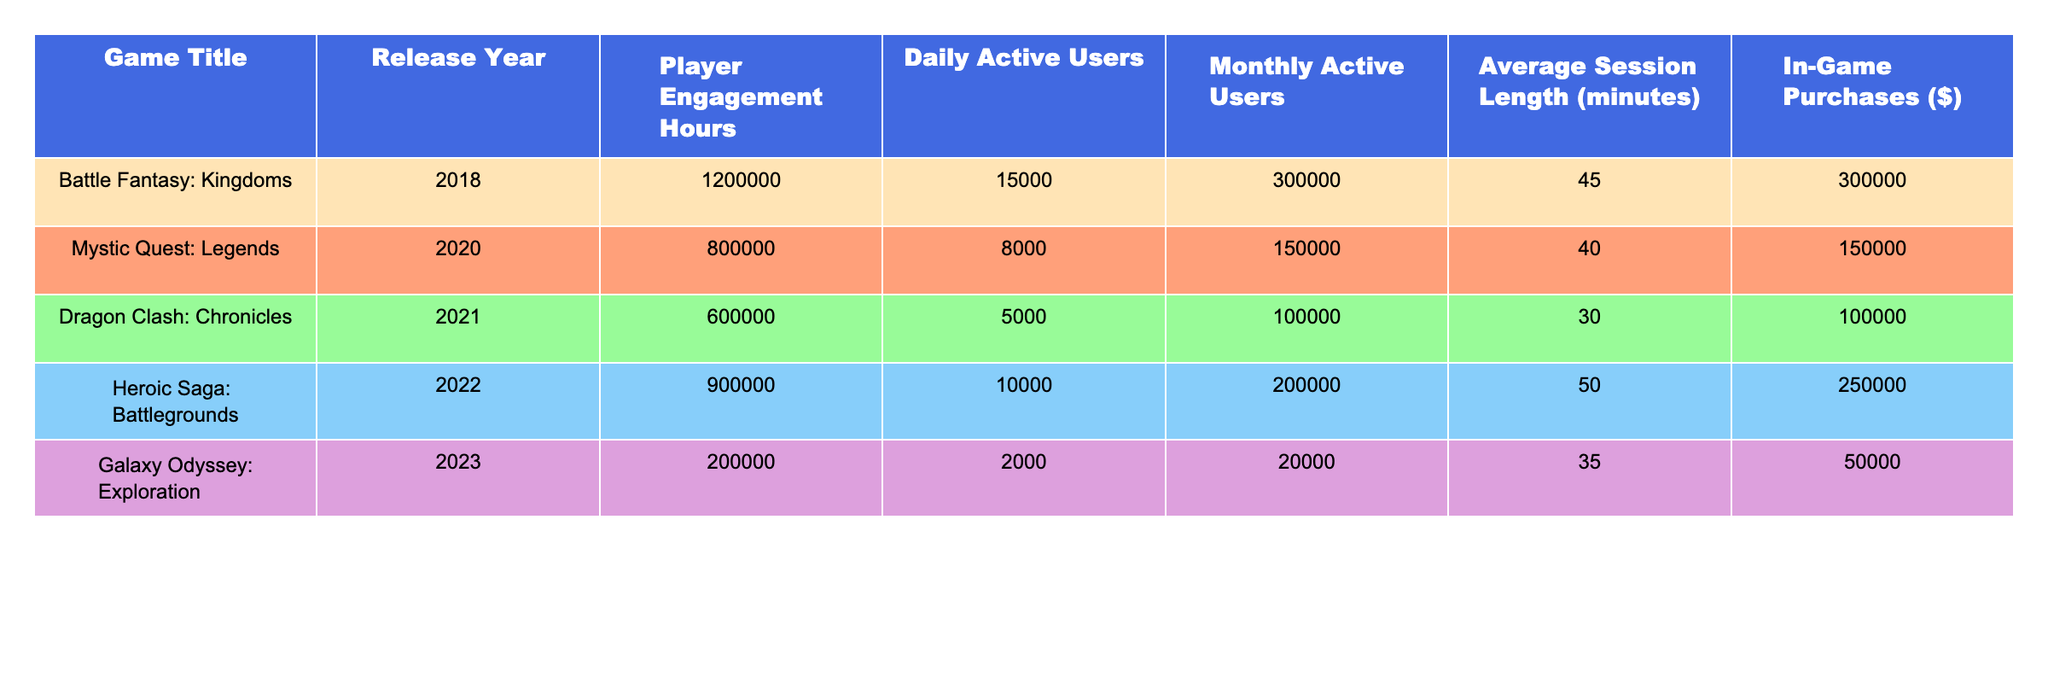What is the game with the highest number of player engagement hours? The game with the highest number of player engagement hours is "Battle Fantasy: Kingdoms" with 1,200,000 hours.
Answer: Battle Fantasy: Kingdoms What is the average session length of "Dragon Clash: Chronicles"? The average session length of "Dragon Clash: Chronicles" is 30 minutes.
Answer: 30 minutes How much in-game purchase revenue did "Heroic Saga: Battlegrounds" generate? "Heroic Saga: Battlegrounds" generated $250,000 in in-game purchases.
Answer: $250,000 Which game had the lowest daily active users? "Galaxy Odyssey: Exploration" had the lowest daily active users with 2,000 users.
Answer: Galaxy Odyssey: Exploration What is the total player engagement hours for all games combined? Summing the player engagement hours gives 1,200,000 + 800,000 + 600,000 + 900,000 + 200,000 = 2,700,000 hours.
Answer: 2,700,000 hours Is the average number of daily active users greater than 10,000 across all games? The average number of daily active users is (15000 + 8000 + 5000 + 10000 + 2000) / 5 = 8,000, which is less than 10,000.
Answer: No Which game shows the largest difference between monthly and daily active users? "Battle Fantasy: Kingdoms" has the largest difference: 300,000 - 15,000 = 285,000.
Answer: Battle Fantasy: Kingdoms What is the total revenue from in-game purchases for "Mystic Quest: Legends" and "Galaxy Odyssey: Exploration"? The sum of in-game purchases for these two games is $150,000 + $50,000 = $200,000.
Answer: $200,000 What percentage of player engagement hours did "Heroic Saga: Battlegrounds" contribute to the total player engagement? "Heroic Saga: Battlegrounds" contributed (900,000 / 2,700,000) * 100 = 33.33%.
Answer: 33.33% Which games were released after 2020? The games released after 2020 are "Dragon Clash: Chronicles", "Heroic Saga: Battlegrounds", and "Galaxy Odyssey: Exploration".
Answer: Dragon Clash: Chronicles, Heroic Saga: Battlegrounds, Galaxy Odyssey: Exploration 